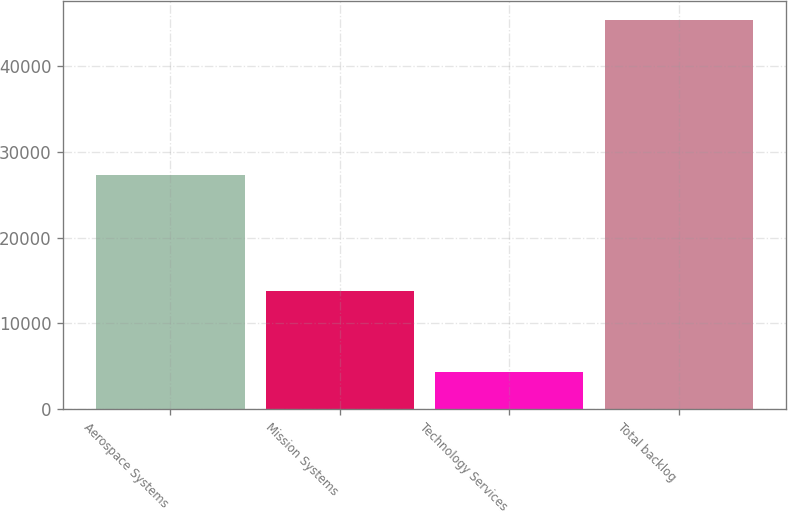<chart> <loc_0><loc_0><loc_500><loc_500><bar_chart><fcel>Aerospace Systems<fcel>Mission Systems<fcel>Technology Services<fcel>Total backlog<nl><fcel>27310<fcel>13715<fcel>4314<fcel>45339<nl></chart> 